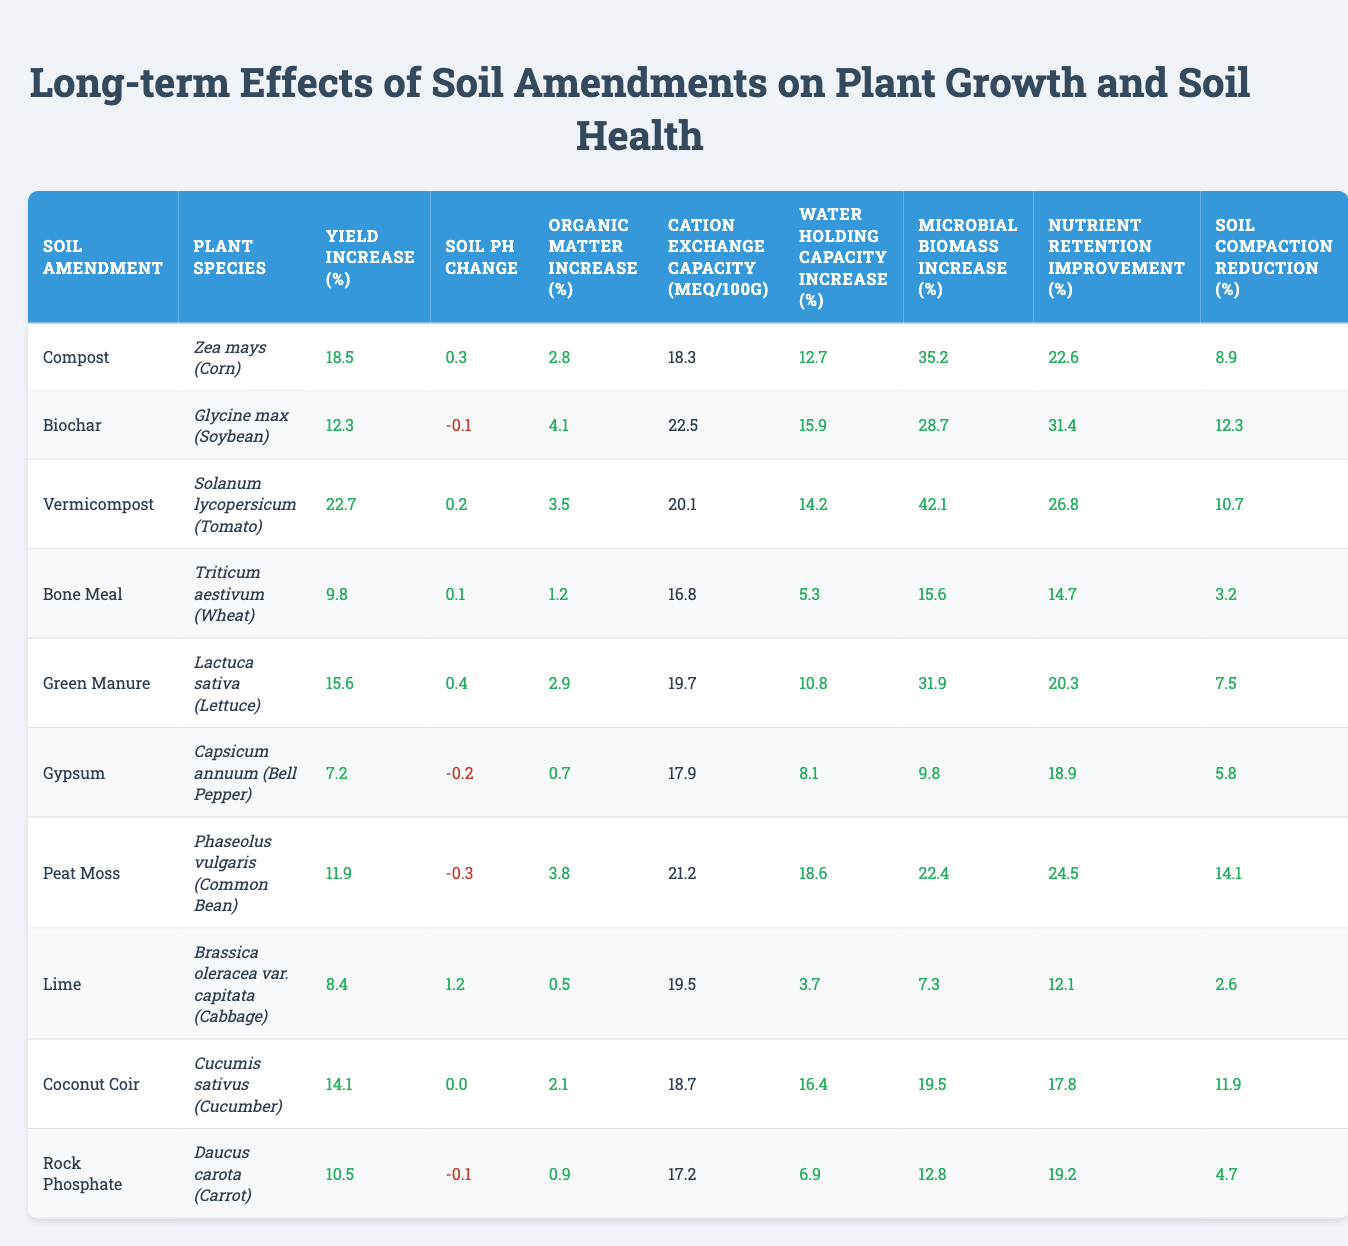What is the yield increase percentage for Zea mays (Corn) with Compost? According to the table, the yield increase percentage for Zea mays (Corn) when treated with Compost is 18.5%.
Answer: 18.5% Which soil amendment resulted in the highest microbial biomass increase? By scanning the microbial biomass increase column, the highest value is 42.1%, associated with Vermicompost.
Answer: Vermicompost Is there a negative change in soil pH for any of the soil amendments? The table indicates that several amendments have negative soil pH changes: Biochar (-0.1), Gypsum (-0.2), and Phaseolus vulgaris (Common Bean), which has a negative observation of -0.3. Therefore, there are indeed negative changes in soil pH.
Answer: Yes What is the average yield increase percentage for all soil amendments? First, we sum the yield increase percentages: 18.5 + 12.3 + 22.7 + 9.8 + 15.6 + 7.2 + 11.9 + 8.4 + 14.1 + 10.5 =  113.0. There are 10 soil amendments, thus the average is 113.0 / 10 = 11.3.
Answer: 11.3 Which plant species had the highest cation exchange capacity? The table shows that the highest cation exchange capacity is associated with Biochar, which has a value of 22.5 meq/100g.
Answer: Biochar What is the difference in organic matter increase percentage between Bone Meal and Vermicompost? Bone Meal shows an organic matter increase of 1.2%, while Vermicompost shows 3.5%. The difference is 3.5% - 1.2% = 2.3%.
Answer: 2.3% Which soil amendment resulted in the lowest soil compaction reduction? Looking at the soil compaction reduction percentages, Bone Meal produced the lowest reduction at 3.2%.
Answer: Bone Meal Does Lime improve water holding capacity more than Compost? According to the table, Lime has a water holding capacity increase of 0.0%, while Compost has an increase of 12.7%. Therefore, Lime does not improve water holding capacity more than Compost.
Answer: No What are the total increases in nutrient retention improvement for all amendments combined? The sums of the nutrient retention improvements are: 22.6 + 31.4 + 26.8 + 14.7 + 20.3 + 18.9 + 24.5 + 12.1 + 17.8 + 19.2 =  195.3%. This represents the total improvement across all amendments.
Answer: 195.3% Which soil amendment has the highest percentage increase in water holding capacity? From the water holding capacity increase column, the highest percentage increase is 18.6%, which is associated with Phaseolus vulgaris (Common Bean).
Answer: Phaseolus vulgaris (Common Bean) 